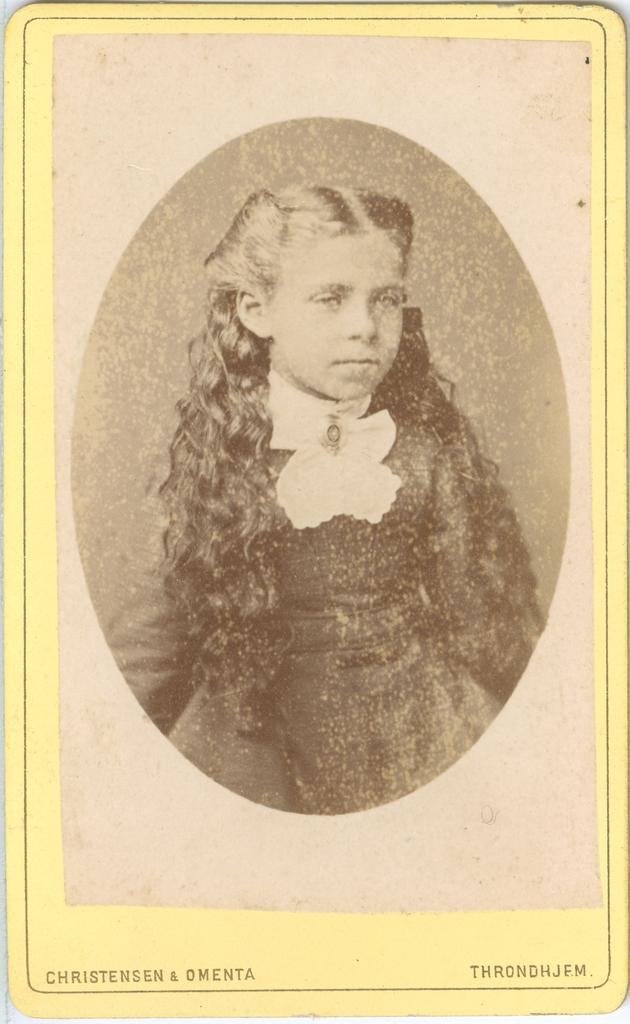What is the main subject of the image? There is a photo of a person in the image. Can you describe any additional elements in the image? There is text at the bottom of the image. What type of trouble is the person in the image experiencing with the string? There is no trouble, person, or string present in the image. 